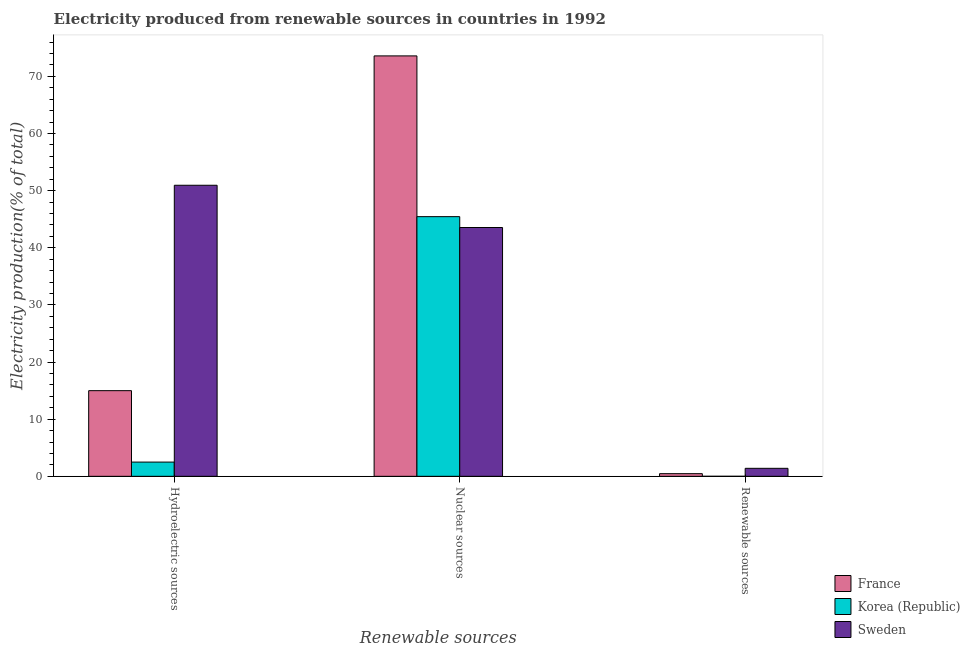How many groups of bars are there?
Your response must be concise. 3. Are the number of bars on each tick of the X-axis equal?
Offer a very short reply. Yes. How many bars are there on the 2nd tick from the left?
Your response must be concise. 3. How many bars are there on the 3rd tick from the right?
Make the answer very short. 3. What is the label of the 2nd group of bars from the left?
Make the answer very short. Nuclear sources. What is the percentage of electricity produced by renewable sources in Korea (Republic)?
Your answer should be very brief. 0. Across all countries, what is the maximum percentage of electricity produced by hydroelectric sources?
Give a very brief answer. 50.93. Across all countries, what is the minimum percentage of electricity produced by hydroelectric sources?
Make the answer very short. 2.49. What is the total percentage of electricity produced by renewable sources in the graph?
Ensure brevity in your answer.  1.86. What is the difference between the percentage of electricity produced by renewable sources in Sweden and that in France?
Offer a very short reply. 0.93. What is the difference between the percentage of electricity produced by hydroelectric sources in Sweden and the percentage of electricity produced by renewable sources in Korea (Republic)?
Your answer should be compact. 50.93. What is the average percentage of electricity produced by renewable sources per country?
Your response must be concise. 0.62. What is the difference between the percentage of electricity produced by nuclear sources and percentage of electricity produced by hydroelectric sources in France?
Your answer should be compact. 58.58. In how many countries, is the percentage of electricity produced by renewable sources greater than 60 %?
Give a very brief answer. 0. What is the ratio of the percentage of electricity produced by renewable sources in Sweden to that in France?
Keep it short and to the point. 3.01. Is the percentage of electricity produced by hydroelectric sources in Korea (Republic) less than that in Sweden?
Your response must be concise. Yes. What is the difference between the highest and the second highest percentage of electricity produced by renewable sources?
Give a very brief answer. 0.93. What is the difference between the highest and the lowest percentage of electricity produced by renewable sources?
Provide a succinct answer. 1.4. Is the sum of the percentage of electricity produced by renewable sources in Sweden and Korea (Republic) greater than the maximum percentage of electricity produced by hydroelectric sources across all countries?
Your answer should be compact. No. Are all the bars in the graph horizontal?
Your response must be concise. No. How many countries are there in the graph?
Your answer should be compact. 3. What is the difference between two consecutive major ticks on the Y-axis?
Your answer should be very brief. 10. Where does the legend appear in the graph?
Offer a terse response. Bottom right. What is the title of the graph?
Ensure brevity in your answer.  Electricity produced from renewable sources in countries in 1992. What is the label or title of the X-axis?
Provide a succinct answer. Renewable sources. What is the label or title of the Y-axis?
Offer a very short reply. Electricity production(% of total). What is the Electricity production(% of total) in France in Hydroelectric sources?
Your response must be concise. 14.99. What is the Electricity production(% of total) in Korea (Republic) in Hydroelectric sources?
Your answer should be compact. 2.49. What is the Electricity production(% of total) in Sweden in Hydroelectric sources?
Offer a very short reply. 50.93. What is the Electricity production(% of total) of France in Nuclear sources?
Give a very brief answer. 73.57. What is the Electricity production(% of total) in Korea (Republic) in Nuclear sources?
Your answer should be compact. 45.44. What is the Electricity production(% of total) in Sweden in Nuclear sources?
Your response must be concise. 43.54. What is the Electricity production(% of total) of France in Renewable sources?
Make the answer very short. 0.46. What is the Electricity production(% of total) of Korea (Republic) in Renewable sources?
Give a very brief answer. 0. What is the Electricity production(% of total) of Sweden in Renewable sources?
Ensure brevity in your answer.  1.4. Across all Renewable sources, what is the maximum Electricity production(% of total) of France?
Provide a short and direct response. 73.57. Across all Renewable sources, what is the maximum Electricity production(% of total) of Korea (Republic)?
Provide a short and direct response. 45.44. Across all Renewable sources, what is the maximum Electricity production(% of total) in Sweden?
Offer a terse response. 50.93. Across all Renewable sources, what is the minimum Electricity production(% of total) in France?
Make the answer very short. 0.46. Across all Renewable sources, what is the minimum Electricity production(% of total) in Korea (Republic)?
Provide a short and direct response. 0. Across all Renewable sources, what is the minimum Electricity production(% of total) of Sweden?
Your response must be concise. 1.4. What is the total Electricity production(% of total) of France in the graph?
Keep it short and to the point. 89.03. What is the total Electricity production(% of total) of Korea (Republic) in the graph?
Give a very brief answer. 47.93. What is the total Electricity production(% of total) of Sweden in the graph?
Keep it short and to the point. 95.88. What is the difference between the Electricity production(% of total) in France in Hydroelectric sources and that in Nuclear sources?
Your answer should be compact. -58.58. What is the difference between the Electricity production(% of total) of Korea (Republic) in Hydroelectric sources and that in Nuclear sources?
Make the answer very short. -42.95. What is the difference between the Electricity production(% of total) in Sweden in Hydroelectric sources and that in Nuclear sources?
Provide a succinct answer. 7.39. What is the difference between the Electricity production(% of total) of France in Hydroelectric sources and that in Renewable sources?
Your answer should be very brief. 14.53. What is the difference between the Electricity production(% of total) in Korea (Republic) in Hydroelectric sources and that in Renewable sources?
Keep it short and to the point. 2.49. What is the difference between the Electricity production(% of total) in Sweden in Hydroelectric sources and that in Renewable sources?
Your answer should be very brief. 49.54. What is the difference between the Electricity production(% of total) of France in Nuclear sources and that in Renewable sources?
Provide a succinct answer. 73.11. What is the difference between the Electricity production(% of total) in Korea (Republic) in Nuclear sources and that in Renewable sources?
Your answer should be compact. 45.44. What is the difference between the Electricity production(% of total) of Sweden in Nuclear sources and that in Renewable sources?
Provide a succinct answer. 42.14. What is the difference between the Electricity production(% of total) in France in Hydroelectric sources and the Electricity production(% of total) in Korea (Republic) in Nuclear sources?
Offer a terse response. -30.45. What is the difference between the Electricity production(% of total) of France in Hydroelectric sources and the Electricity production(% of total) of Sweden in Nuclear sources?
Offer a very short reply. -28.55. What is the difference between the Electricity production(% of total) in Korea (Republic) in Hydroelectric sources and the Electricity production(% of total) in Sweden in Nuclear sources?
Keep it short and to the point. -41.05. What is the difference between the Electricity production(% of total) of France in Hydroelectric sources and the Electricity production(% of total) of Korea (Republic) in Renewable sources?
Provide a succinct answer. 14.99. What is the difference between the Electricity production(% of total) in France in Hydroelectric sources and the Electricity production(% of total) in Sweden in Renewable sources?
Give a very brief answer. 13.59. What is the difference between the Electricity production(% of total) of Korea (Republic) in Hydroelectric sources and the Electricity production(% of total) of Sweden in Renewable sources?
Make the answer very short. 1.09. What is the difference between the Electricity production(% of total) of France in Nuclear sources and the Electricity production(% of total) of Korea (Republic) in Renewable sources?
Give a very brief answer. 73.57. What is the difference between the Electricity production(% of total) in France in Nuclear sources and the Electricity production(% of total) in Sweden in Renewable sources?
Keep it short and to the point. 72.17. What is the difference between the Electricity production(% of total) in Korea (Republic) in Nuclear sources and the Electricity production(% of total) in Sweden in Renewable sources?
Offer a terse response. 44.04. What is the average Electricity production(% of total) of France per Renewable sources?
Your answer should be compact. 29.68. What is the average Electricity production(% of total) in Korea (Republic) per Renewable sources?
Ensure brevity in your answer.  15.98. What is the average Electricity production(% of total) in Sweden per Renewable sources?
Ensure brevity in your answer.  31.96. What is the difference between the Electricity production(% of total) in France and Electricity production(% of total) in Korea (Republic) in Hydroelectric sources?
Keep it short and to the point. 12.5. What is the difference between the Electricity production(% of total) of France and Electricity production(% of total) of Sweden in Hydroelectric sources?
Make the answer very short. -35.94. What is the difference between the Electricity production(% of total) in Korea (Republic) and Electricity production(% of total) in Sweden in Hydroelectric sources?
Provide a succinct answer. -48.45. What is the difference between the Electricity production(% of total) of France and Electricity production(% of total) of Korea (Republic) in Nuclear sources?
Your response must be concise. 28.13. What is the difference between the Electricity production(% of total) in France and Electricity production(% of total) in Sweden in Nuclear sources?
Offer a very short reply. 30.03. What is the difference between the Electricity production(% of total) of Korea (Republic) and Electricity production(% of total) of Sweden in Nuclear sources?
Make the answer very short. 1.9. What is the difference between the Electricity production(% of total) of France and Electricity production(% of total) of Korea (Republic) in Renewable sources?
Provide a short and direct response. 0.46. What is the difference between the Electricity production(% of total) in France and Electricity production(% of total) in Sweden in Renewable sources?
Offer a terse response. -0.93. What is the difference between the Electricity production(% of total) of Korea (Republic) and Electricity production(% of total) of Sweden in Renewable sources?
Provide a short and direct response. -1.4. What is the ratio of the Electricity production(% of total) in France in Hydroelectric sources to that in Nuclear sources?
Offer a terse response. 0.2. What is the ratio of the Electricity production(% of total) in Korea (Republic) in Hydroelectric sources to that in Nuclear sources?
Your answer should be very brief. 0.05. What is the ratio of the Electricity production(% of total) of Sweden in Hydroelectric sources to that in Nuclear sources?
Keep it short and to the point. 1.17. What is the ratio of the Electricity production(% of total) in France in Hydroelectric sources to that in Renewable sources?
Keep it short and to the point. 32.31. What is the ratio of the Electricity production(% of total) in Korea (Republic) in Hydroelectric sources to that in Renewable sources?
Your answer should be very brief. 1548.5. What is the ratio of the Electricity production(% of total) in Sweden in Hydroelectric sources to that in Renewable sources?
Provide a succinct answer. 36.42. What is the ratio of the Electricity production(% of total) in France in Nuclear sources to that in Renewable sources?
Your answer should be very brief. 158.6. What is the ratio of the Electricity production(% of total) of Korea (Republic) in Nuclear sources to that in Renewable sources?
Your answer should be very brief. 2.83e+04. What is the ratio of the Electricity production(% of total) in Sweden in Nuclear sources to that in Renewable sources?
Your answer should be very brief. 31.13. What is the difference between the highest and the second highest Electricity production(% of total) in France?
Ensure brevity in your answer.  58.58. What is the difference between the highest and the second highest Electricity production(% of total) of Korea (Republic)?
Provide a succinct answer. 42.95. What is the difference between the highest and the second highest Electricity production(% of total) in Sweden?
Your answer should be very brief. 7.39. What is the difference between the highest and the lowest Electricity production(% of total) in France?
Your response must be concise. 73.11. What is the difference between the highest and the lowest Electricity production(% of total) of Korea (Republic)?
Ensure brevity in your answer.  45.44. What is the difference between the highest and the lowest Electricity production(% of total) of Sweden?
Offer a terse response. 49.54. 